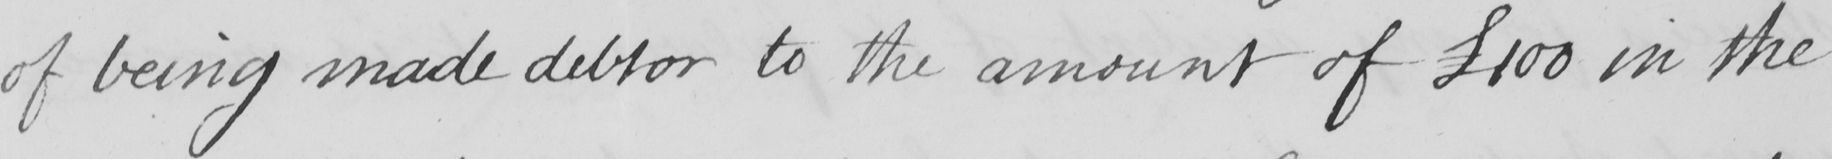What text is written in this handwritten line? of being made debtor to the amount of  £100 in the 